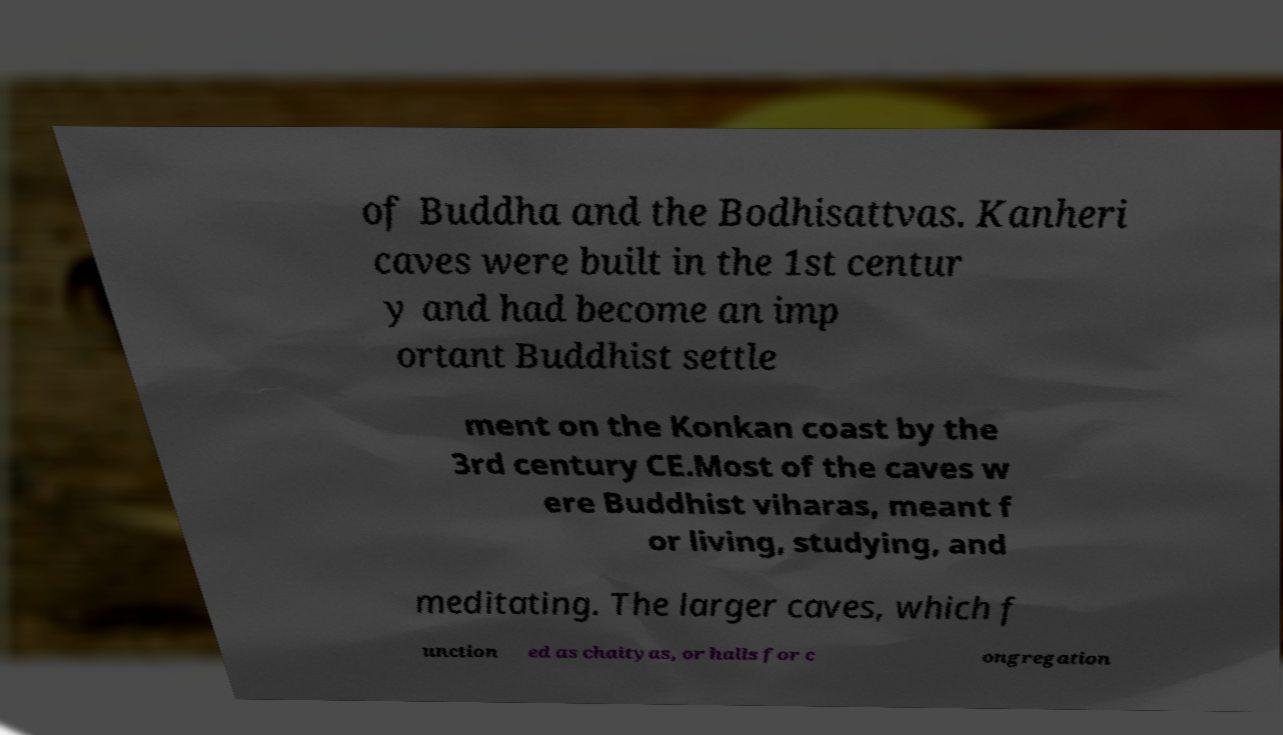Please identify and transcribe the text found in this image. of Buddha and the Bodhisattvas. Kanheri caves were built in the 1st centur y and had become an imp ortant Buddhist settle ment on the Konkan coast by the 3rd century CE.Most of the caves w ere Buddhist viharas, meant f or living, studying, and meditating. The larger caves, which f unction ed as chaityas, or halls for c ongregation 